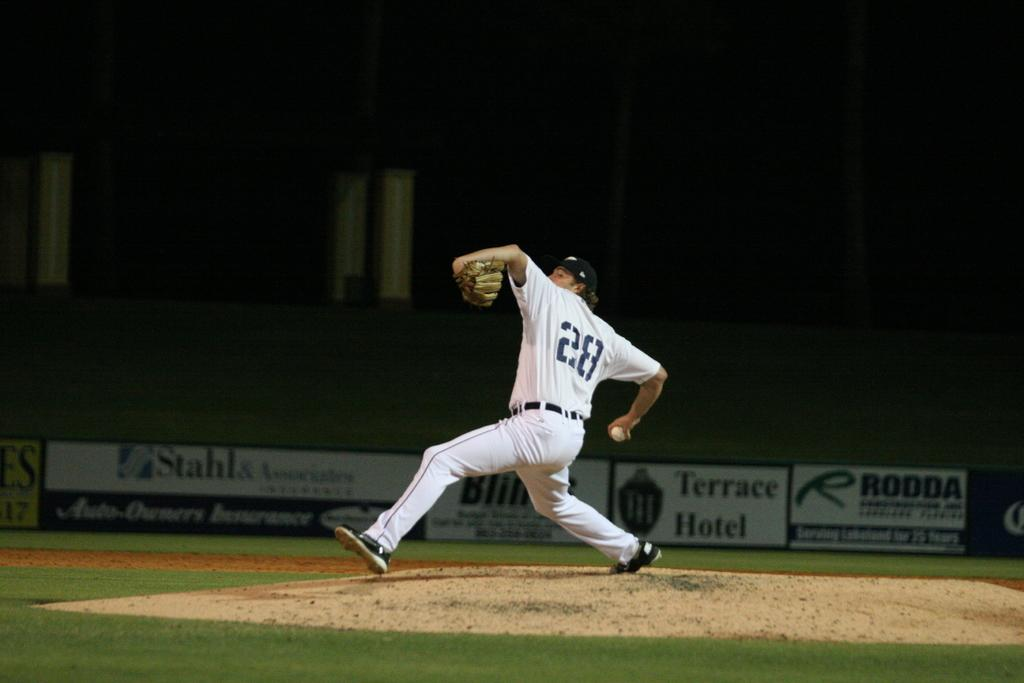<image>
Render a clear and concise summary of the photo. Baseball player wearing number 28 throwing a pitch. 